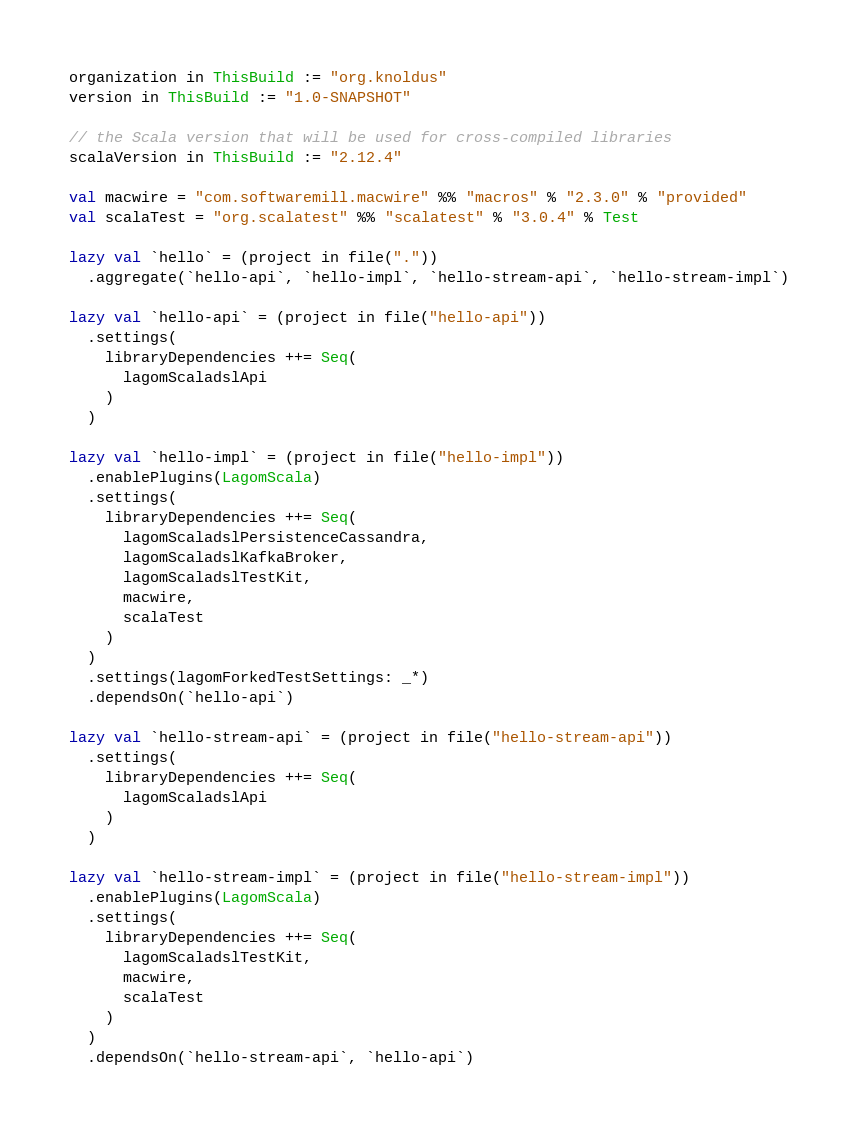Convert code to text. <code><loc_0><loc_0><loc_500><loc_500><_Scala_>organization in ThisBuild := "org.knoldus"
version in ThisBuild := "1.0-SNAPSHOT"

// the Scala version that will be used for cross-compiled libraries
scalaVersion in ThisBuild := "2.12.4"

val macwire = "com.softwaremill.macwire" %% "macros" % "2.3.0" % "provided"
val scalaTest = "org.scalatest" %% "scalatest" % "3.0.4" % Test

lazy val `hello` = (project in file("."))
  .aggregate(`hello-api`, `hello-impl`, `hello-stream-api`, `hello-stream-impl`)

lazy val `hello-api` = (project in file("hello-api"))
  .settings(
    libraryDependencies ++= Seq(
      lagomScaladslApi
    )
  )

lazy val `hello-impl` = (project in file("hello-impl"))
  .enablePlugins(LagomScala)
  .settings(
    libraryDependencies ++= Seq(
      lagomScaladslPersistenceCassandra,
      lagomScaladslKafkaBroker,
      lagomScaladslTestKit,
      macwire,
      scalaTest
    )
  )
  .settings(lagomForkedTestSettings: _*)
  .dependsOn(`hello-api`)

lazy val `hello-stream-api` = (project in file("hello-stream-api"))
  .settings(
    libraryDependencies ++= Seq(
      lagomScaladslApi
    )
  )

lazy val `hello-stream-impl` = (project in file("hello-stream-impl"))
  .enablePlugins(LagomScala)
  .settings(
    libraryDependencies ++= Seq(
      lagomScaladslTestKit,
      macwire,
      scalaTest
    )
  )
  .dependsOn(`hello-stream-api`, `hello-api`)
</code> 